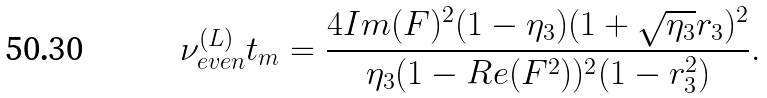<formula> <loc_0><loc_0><loc_500><loc_500>\nu _ { e v e n } ^ { ( L ) } t _ { m } = \frac { 4 I m ( F ) ^ { 2 } ( 1 - \eta _ { 3 } ) ( 1 + \sqrt { \eta _ { 3 } } r _ { 3 } ) ^ { 2 } } { \eta _ { 3 } ( 1 - R e ( F ^ { 2 } ) ) ^ { 2 } ( 1 - r _ { 3 } ^ { 2 } ) } .</formula> 